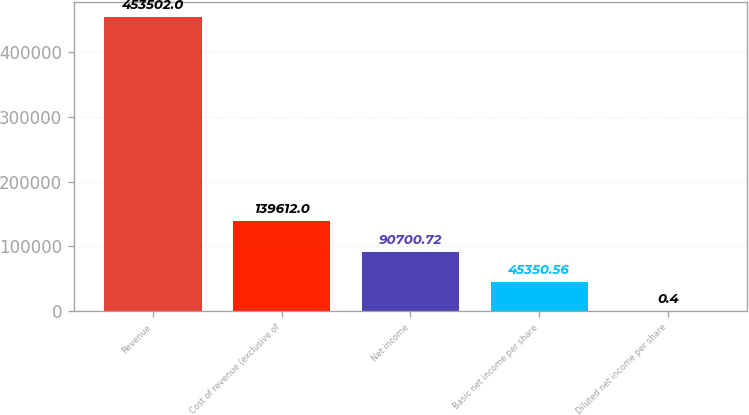Convert chart. <chart><loc_0><loc_0><loc_500><loc_500><bar_chart><fcel>Revenue<fcel>Cost of revenue (exclusive of<fcel>Net income<fcel>Basic net income per share<fcel>Diluted net income per share<nl><fcel>453502<fcel>139612<fcel>90700.7<fcel>45350.6<fcel>0.4<nl></chart> 